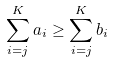<formula> <loc_0><loc_0><loc_500><loc_500>\sum _ { i = j } ^ { K } a _ { i } \geq \sum _ { i = j } ^ { K } b _ { i }</formula> 